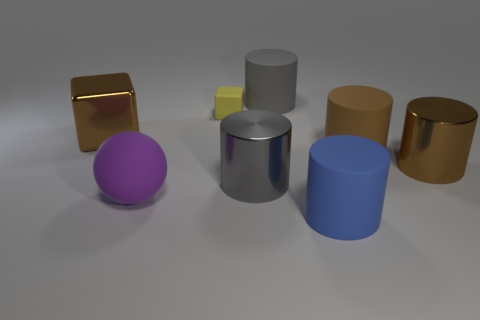Subtract all blue cylinders. How many cylinders are left? 4 Subtract all blue matte cylinders. How many cylinders are left? 4 Subtract all red cylinders. Subtract all cyan blocks. How many cylinders are left? 5 Add 1 large brown matte objects. How many objects exist? 9 Subtract all blocks. How many objects are left? 6 Subtract all green metal balls. Subtract all large purple matte balls. How many objects are left? 7 Add 7 blue matte objects. How many blue matte objects are left? 8 Add 5 cylinders. How many cylinders exist? 10 Subtract 0 cyan cylinders. How many objects are left? 8 